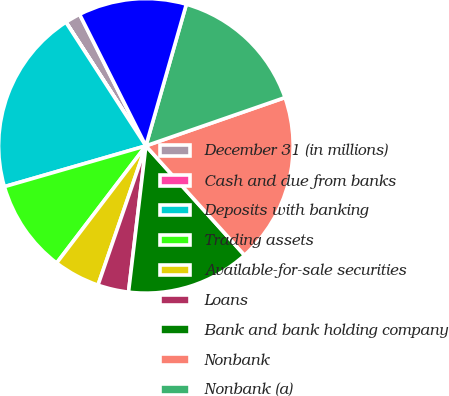Convert chart to OTSL. <chart><loc_0><loc_0><loc_500><loc_500><pie_chart><fcel>December 31 (in millions)<fcel>Cash and due from banks<fcel>Deposits with banking<fcel>Trading assets<fcel>Available-for-sale securities<fcel>Loans<fcel>Bank and bank holding company<fcel>Nonbank<fcel>Nonbank (a)<fcel>Other assets<nl><fcel>1.7%<fcel>0.01%<fcel>20.33%<fcel>10.17%<fcel>5.09%<fcel>3.39%<fcel>13.56%<fcel>18.64%<fcel>15.25%<fcel>11.86%<nl></chart> 